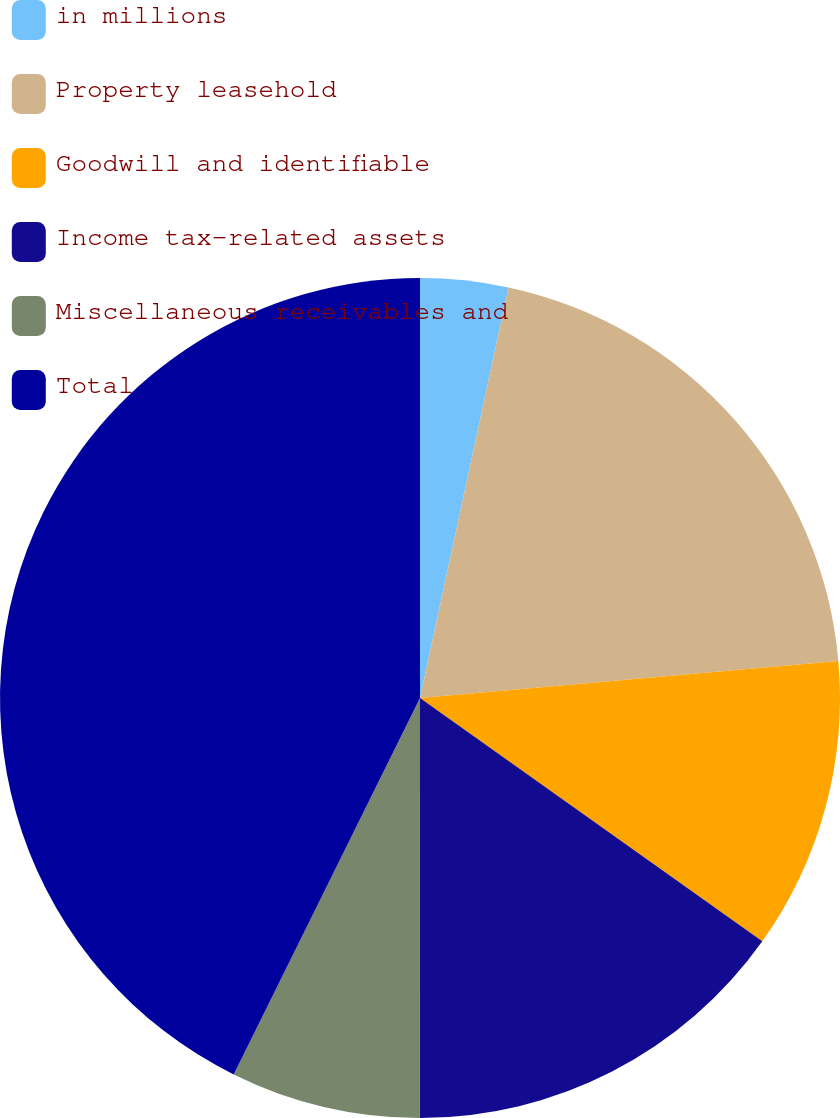Convert chart to OTSL. <chart><loc_0><loc_0><loc_500><loc_500><pie_chart><fcel>in millions<fcel>Property leasehold<fcel>Goodwill and identifiable<fcel>Income tax-related assets<fcel>Miscellaneous receivables and<fcel>Total<nl><fcel>3.38%<fcel>20.22%<fcel>11.24%<fcel>15.17%<fcel>7.31%<fcel>42.69%<nl></chart> 